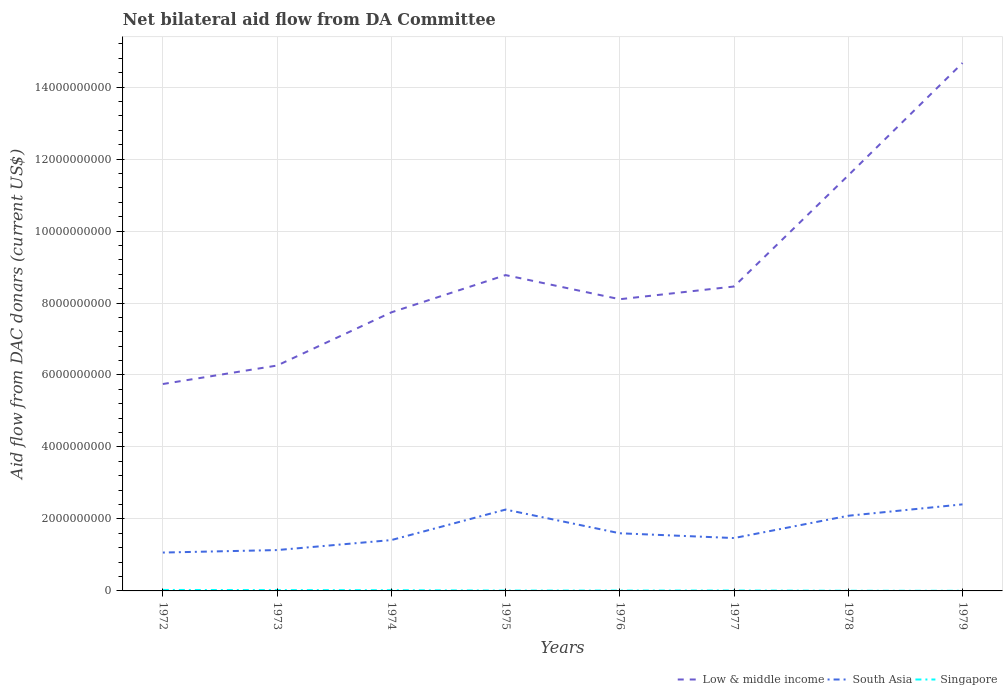Does the line corresponding to South Asia intersect with the line corresponding to Singapore?
Make the answer very short. No. Is the number of lines equal to the number of legend labels?
Offer a terse response. Yes. Across all years, what is the maximum aid flow in in Singapore?
Your answer should be very brief. 3.93e+06. In which year was the aid flow in in Low & middle income maximum?
Provide a short and direct response. 1972. What is the total aid flow in in Low & middle income in the graph?
Make the answer very short. -1.48e+09. What is the difference between the highest and the second highest aid flow in in Singapore?
Offer a very short reply. 2.31e+07. Is the aid flow in in South Asia strictly greater than the aid flow in in Singapore over the years?
Give a very brief answer. No. How many lines are there?
Your response must be concise. 3. Are the values on the major ticks of Y-axis written in scientific E-notation?
Provide a short and direct response. No. Does the graph contain any zero values?
Provide a short and direct response. No. How many legend labels are there?
Make the answer very short. 3. How are the legend labels stacked?
Offer a terse response. Horizontal. What is the title of the graph?
Your response must be concise. Net bilateral aid flow from DA Committee. Does "Botswana" appear as one of the legend labels in the graph?
Your response must be concise. No. What is the label or title of the X-axis?
Your answer should be very brief. Years. What is the label or title of the Y-axis?
Offer a very short reply. Aid flow from DAC donars (current US$). What is the Aid flow from DAC donars (current US$) of Low & middle income in 1972?
Your answer should be very brief. 5.75e+09. What is the Aid flow from DAC donars (current US$) in South Asia in 1972?
Offer a very short reply. 1.07e+09. What is the Aid flow from DAC donars (current US$) in Singapore in 1972?
Your answer should be compact. 2.70e+07. What is the Aid flow from DAC donars (current US$) in Low & middle income in 1973?
Offer a very short reply. 6.26e+09. What is the Aid flow from DAC donars (current US$) in South Asia in 1973?
Your answer should be very brief. 1.14e+09. What is the Aid flow from DAC donars (current US$) of Singapore in 1973?
Make the answer very short. 2.32e+07. What is the Aid flow from DAC donars (current US$) in Low & middle income in 1974?
Provide a short and direct response. 7.74e+09. What is the Aid flow from DAC donars (current US$) of South Asia in 1974?
Ensure brevity in your answer.  1.41e+09. What is the Aid flow from DAC donars (current US$) in Singapore in 1974?
Provide a succinct answer. 1.97e+07. What is the Aid flow from DAC donars (current US$) of Low & middle income in 1975?
Provide a succinct answer. 8.78e+09. What is the Aid flow from DAC donars (current US$) in South Asia in 1975?
Your answer should be compact. 2.26e+09. What is the Aid flow from DAC donars (current US$) of Singapore in 1975?
Provide a short and direct response. 1.00e+07. What is the Aid flow from DAC donars (current US$) in Low & middle income in 1976?
Provide a succinct answer. 8.11e+09. What is the Aid flow from DAC donars (current US$) in South Asia in 1976?
Keep it short and to the point. 1.60e+09. What is the Aid flow from DAC donars (current US$) of Singapore in 1976?
Make the answer very short. 9.98e+06. What is the Aid flow from DAC donars (current US$) in Low & middle income in 1977?
Your answer should be very brief. 8.46e+09. What is the Aid flow from DAC donars (current US$) in South Asia in 1977?
Your answer should be very brief. 1.47e+09. What is the Aid flow from DAC donars (current US$) of Singapore in 1977?
Keep it short and to the point. 1.13e+07. What is the Aid flow from DAC donars (current US$) in Low & middle income in 1978?
Offer a very short reply. 1.15e+1. What is the Aid flow from DAC donars (current US$) in South Asia in 1978?
Your answer should be compact. 2.09e+09. What is the Aid flow from DAC donars (current US$) of Singapore in 1978?
Make the answer very short. 5.19e+06. What is the Aid flow from DAC donars (current US$) of Low & middle income in 1979?
Give a very brief answer. 1.47e+1. What is the Aid flow from DAC donars (current US$) in South Asia in 1979?
Your answer should be compact. 2.40e+09. What is the Aid flow from DAC donars (current US$) of Singapore in 1979?
Your response must be concise. 3.93e+06. Across all years, what is the maximum Aid flow from DAC donars (current US$) of Low & middle income?
Provide a succinct answer. 1.47e+1. Across all years, what is the maximum Aid flow from DAC donars (current US$) of South Asia?
Give a very brief answer. 2.40e+09. Across all years, what is the maximum Aid flow from DAC donars (current US$) of Singapore?
Your answer should be very brief. 2.70e+07. Across all years, what is the minimum Aid flow from DAC donars (current US$) in Low & middle income?
Provide a succinct answer. 5.75e+09. Across all years, what is the minimum Aid flow from DAC donars (current US$) of South Asia?
Offer a terse response. 1.07e+09. Across all years, what is the minimum Aid flow from DAC donars (current US$) of Singapore?
Give a very brief answer. 3.93e+06. What is the total Aid flow from DAC donars (current US$) of Low & middle income in the graph?
Give a very brief answer. 7.13e+1. What is the total Aid flow from DAC donars (current US$) in South Asia in the graph?
Your answer should be compact. 1.34e+1. What is the total Aid flow from DAC donars (current US$) in Singapore in the graph?
Provide a short and direct response. 1.10e+08. What is the difference between the Aid flow from DAC donars (current US$) of Low & middle income in 1972 and that in 1973?
Give a very brief answer. -5.14e+08. What is the difference between the Aid flow from DAC donars (current US$) in South Asia in 1972 and that in 1973?
Provide a short and direct response. -6.90e+07. What is the difference between the Aid flow from DAC donars (current US$) in Singapore in 1972 and that in 1973?
Your answer should be compact. 3.88e+06. What is the difference between the Aid flow from DAC donars (current US$) of Low & middle income in 1972 and that in 1974?
Keep it short and to the point. -1.99e+09. What is the difference between the Aid flow from DAC donars (current US$) of South Asia in 1972 and that in 1974?
Provide a succinct answer. -3.47e+08. What is the difference between the Aid flow from DAC donars (current US$) of Singapore in 1972 and that in 1974?
Offer a very short reply. 7.34e+06. What is the difference between the Aid flow from DAC donars (current US$) of Low & middle income in 1972 and that in 1975?
Your response must be concise. -3.03e+09. What is the difference between the Aid flow from DAC donars (current US$) in South Asia in 1972 and that in 1975?
Provide a succinct answer. -1.19e+09. What is the difference between the Aid flow from DAC donars (current US$) of Singapore in 1972 and that in 1975?
Ensure brevity in your answer.  1.70e+07. What is the difference between the Aid flow from DAC donars (current US$) of Low & middle income in 1972 and that in 1976?
Ensure brevity in your answer.  -2.36e+09. What is the difference between the Aid flow from DAC donars (current US$) in South Asia in 1972 and that in 1976?
Your answer should be compact. -5.35e+08. What is the difference between the Aid flow from DAC donars (current US$) in Singapore in 1972 and that in 1976?
Offer a very short reply. 1.70e+07. What is the difference between the Aid flow from DAC donars (current US$) of Low & middle income in 1972 and that in 1977?
Keep it short and to the point. -2.71e+09. What is the difference between the Aid flow from DAC donars (current US$) of South Asia in 1972 and that in 1977?
Offer a terse response. -4.03e+08. What is the difference between the Aid flow from DAC donars (current US$) in Singapore in 1972 and that in 1977?
Your answer should be very brief. 1.58e+07. What is the difference between the Aid flow from DAC donars (current US$) of Low & middle income in 1972 and that in 1978?
Offer a very short reply. -5.80e+09. What is the difference between the Aid flow from DAC donars (current US$) in South Asia in 1972 and that in 1978?
Offer a very short reply. -1.02e+09. What is the difference between the Aid flow from DAC donars (current US$) of Singapore in 1972 and that in 1978?
Provide a succinct answer. 2.18e+07. What is the difference between the Aid flow from DAC donars (current US$) in Low & middle income in 1972 and that in 1979?
Your answer should be very brief. -8.92e+09. What is the difference between the Aid flow from DAC donars (current US$) in South Asia in 1972 and that in 1979?
Your answer should be very brief. -1.34e+09. What is the difference between the Aid flow from DAC donars (current US$) in Singapore in 1972 and that in 1979?
Keep it short and to the point. 2.31e+07. What is the difference between the Aid flow from DAC donars (current US$) of Low & middle income in 1973 and that in 1974?
Your response must be concise. -1.48e+09. What is the difference between the Aid flow from DAC donars (current US$) of South Asia in 1973 and that in 1974?
Your response must be concise. -2.78e+08. What is the difference between the Aid flow from DAC donars (current US$) in Singapore in 1973 and that in 1974?
Your response must be concise. 3.46e+06. What is the difference between the Aid flow from DAC donars (current US$) of Low & middle income in 1973 and that in 1975?
Your answer should be compact. -2.51e+09. What is the difference between the Aid flow from DAC donars (current US$) in South Asia in 1973 and that in 1975?
Your response must be concise. -1.13e+09. What is the difference between the Aid flow from DAC donars (current US$) in Singapore in 1973 and that in 1975?
Provide a succinct answer. 1.31e+07. What is the difference between the Aid flow from DAC donars (current US$) of Low & middle income in 1973 and that in 1976?
Your answer should be very brief. -1.84e+09. What is the difference between the Aid flow from DAC donars (current US$) of South Asia in 1973 and that in 1976?
Your answer should be very brief. -4.67e+08. What is the difference between the Aid flow from DAC donars (current US$) of Singapore in 1973 and that in 1976?
Keep it short and to the point. 1.32e+07. What is the difference between the Aid flow from DAC donars (current US$) in Low & middle income in 1973 and that in 1977?
Your answer should be compact. -2.20e+09. What is the difference between the Aid flow from DAC donars (current US$) in South Asia in 1973 and that in 1977?
Offer a terse response. -3.34e+08. What is the difference between the Aid flow from DAC donars (current US$) of Singapore in 1973 and that in 1977?
Your answer should be very brief. 1.19e+07. What is the difference between the Aid flow from DAC donars (current US$) in Low & middle income in 1973 and that in 1978?
Offer a very short reply. -5.28e+09. What is the difference between the Aid flow from DAC donars (current US$) in South Asia in 1973 and that in 1978?
Give a very brief answer. -9.53e+08. What is the difference between the Aid flow from DAC donars (current US$) in Singapore in 1973 and that in 1978?
Provide a succinct answer. 1.80e+07. What is the difference between the Aid flow from DAC donars (current US$) of Low & middle income in 1973 and that in 1979?
Your answer should be compact. -8.41e+09. What is the difference between the Aid flow from DAC donars (current US$) in South Asia in 1973 and that in 1979?
Provide a succinct answer. -1.27e+09. What is the difference between the Aid flow from DAC donars (current US$) of Singapore in 1973 and that in 1979?
Offer a terse response. 1.92e+07. What is the difference between the Aid flow from DAC donars (current US$) of Low & middle income in 1974 and that in 1975?
Your answer should be very brief. -1.04e+09. What is the difference between the Aid flow from DAC donars (current US$) of South Asia in 1974 and that in 1975?
Provide a short and direct response. -8.47e+08. What is the difference between the Aid flow from DAC donars (current US$) of Singapore in 1974 and that in 1975?
Offer a very short reply. 9.68e+06. What is the difference between the Aid flow from DAC donars (current US$) of Low & middle income in 1974 and that in 1976?
Your answer should be very brief. -3.65e+08. What is the difference between the Aid flow from DAC donars (current US$) of South Asia in 1974 and that in 1976?
Your response must be concise. -1.89e+08. What is the difference between the Aid flow from DAC donars (current US$) in Singapore in 1974 and that in 1976?
Ensure brevity in your answer.  9.71e+06. What is the difference between the Aid flow from DAC donars (current US$) of Low & middle income in 1974 and that in 1977?
Offer a very short reply. -7.19e+08. What is the difference between the Aid flow from DAC donars (current US$) in South Asia in 1974 and that in 1977?
Give a very brief answer. -5.61e+07. What is the difference between the Aid flow from DAC donars (current US$) in Singapore in 1974 and that in 1977?
Give a very brief answer. 8.41e+06. What is the difference between the Aid flow from DAC donars (current US$) of Low & middle income in 1974 and that in 1978?
Provide a short and direct response. -3.81e+09. What is the difference between the Aid flow from DAC donars (current US$) of South Asia in 1974 and that in 1978?
Ensure brevity in your answer.  -6.76e+08. What is the difference between the Aid flow from DAC donars (current US$) of Singapore in 1974 and that in 1978?
Your response must be concise. 1.45e+07. What is the difference between the Aid flow from DAC donars (current US$) in Low & middle income in 1974 and that in 1979?
Give a very brief answer. -6.93e+09. What is the difference between the Aid flow from DAC donars (current US$) in South Asia in 1974 and that in 1979?
Provide a succinct answer. -9.92e+08. What is the difference between the Aid flow from DAC donars (current US$) in Singapore in 1974 and that in 1979?
Make the answer very short. 1.58e+07. What is the difference between the Aid flow from DAC donars (current US$) of Low & middle income in 1975 and that in 1976?
Offer a very short reply. 6.71e+08. What is the difference between the Aid flow from DAC donars (current US$) of South Asia in 1975 and that in 1976?
Provide a short and direct response. 6.59e+08. What is the difference between the Aid flow from DAC donars (current US$) in Singapore in 1975 and that in 1976?
Your answer should be very brief. 3.00e+04. What is the difference between the Aid flow from DAC donars (current US$) in Low & middle income in 1975 and that in 1977?
Offer a very short reply. 3.17e+08. What is the difference between the Aid flow from DAC donars (current US$) in South Asia in 1975 and that in 1977?
Ensure brevity in your answer.  7.91e+08. What is the difference between the Aid flow from DAC donars (current US$) in Singapore in 1975 and that in 1977?
Your response must be concise. -1.27e+06. What is the difference between the Aid flow from DAC donars (current US$) of Low & middle income in 1975 and that in 1978?
Offer a terse response. -2.77e+09. What is the difference between the Aid flow from DAC donars (current US$) in South Asia in 1975 and that in 1978?
Make the answer very short. 1.72e+08. What is the difference between the Aid flow from DAC donars (current US$) of Singapore in 1975 and that in 1978?
Your answer should be compact. 4.82e+06. What is the difference between the Aid flow from DAC donars (current US$) of Low & middle income in 1975 and that in 1979?
Offer a very short reply. -5.89e+09. What is the difference between the Aid flow from DAC donars (current US$) in South Asia in 1975 and that in 1979?
Give a very brief answer. -1.45e+08. What is the difference between the Aid flow from DAC donars (current US$) of Singapore in 1975 and that in 1979?
Make the answer very short. 6.08e+06. What is the difference between the Aid flow from DAC donars (current US$) of Low & middle income in 1976 and that in 1977?
Your answer should be compact. -3.54e+08. What is the difference between the Aid flow from DAC donars (current US$) of South Asia in 1976 and that in 1977?
Offer a terse response. 1.33e+08. What is the difference between the Aid flow from DAC donars (current US$) of Singapore in 1976 and that in 1977?
Give a very brief answer. -1.30e+06. What is the difference between the Aid flow from DAC donars (current US$) of Low & middle income in 1976 and that in 1978?
Make the answer very short. -3.44e+09. What is the difference between the Aid flow from DAC donars (current US$) of South Asia in 1976 and that in 1978?
Provide a succinct answer. -4.87e+08. What is the difference between the Aid flow from DAC donars (current US$) in Singapore in 1976 and that in 1978?
Offer a terse response. 4.79e+06. What is the difference between the Aid flow from DAC donars (current US$) of Low & middle income in 1976 and that in 1979?
Your answer should be very brief. -6.56e+09. What is the difference between the Aid flow from DAC donars (current US$) in South Asia in 1976 and that in 1979?
Make the answer very short. -8.03e+08. What is the difference between the Aid flow from DAC donars (current US$) of Singapore in 1976 and that in 1979?
Your answer should be very brief. 6.05e+06. What is the difference between the Aid flow from DAC donars (current US$) in Low & middle income in 1977 and that in 1978?
Offer a terse response. -3.09e+09. What is the difference between the Aid flow from DAC donars (current US$) in South Asia in 1977 and that in 1978?
Your response must be concise. -6.20e+08. What is the difference between the Aid flow from DAC donars (current US$) of Singapore in 1977 and that in 1978?
Offer a very short reply. 6.09e+06. What is the difference between the Aid flow from DAC donars (current US$) in Low & middle income in 1977 and that in 1979?
Your answer should be compact. -6.21e+09. What is the difference between the Aid flow from DAC donars (current US$) in South Asia in 1977 and that in 1979?
Offer a terse response. -9.36e+08. What is the difference between the Aid flow from DAC donars (current US$) of Singapore in 1977 and that in 1979?
Make the answer very short. 7.35e+06. What is the difference between the Aid flow from DAC donars (current US$) in Low & middle income in 1978 and that in 1979?
Ensure brevity in your answer.  -3.12e+09. What is the difference between the Aid flow from DAC donars (current US$) of South Asia in 1978 and that in 1979?
Your response must be concise. -3.16e+08. What is the difference between the Aid flow from DAC donars (current US$) in Singapore in 1978 and that in 1979?
Provide a short and direct response. 1.26e+06. What is the difference between the Aid flow from DAC donars (current US$) of Low & middle income in 1972 and the Aid flow from DAC donars (current US$) of South Asia in 1973?
Keep it short and to the point. 4.61e+09. What is the difference between the Aid flow from DAC donars (current US$) of Low & middle income in 1972 and the Aid flow from DAC donars (current US$) of Singapore in 1973?
Your answer should be very brief. 5.73e+09. What is the difference between the Aid flow from DAC donars (current US$) of South Asia in 1972 and the Aid flow from DAC donars (current US$) of Singapore in 1973?
Give a very brief answer. 1.04e+09. What is the difference between the Aid flow from DAC donars (current US$) in Low & middle income in 1972 and the Aid flow from DAC donars (current US$) in South Asia in 1974?
Keep it short and to the point. 4.34e+09. What is the difference between the Aid flow from DAC donars (current US$) in Low & middle income in 1972 and the Aid flow from DAC donars (current US$) in Singapore in 1974?
Your answer should be compact. 5.73e+09. What is the difference between the Aid flow from DAC donars (current US$) of South Asia in 1972 and the Aid flow from DAC donars (current US$) of Singapore in 1974?
Make the answer very short. 1.05e+09. What is the difference between the Aid flow from DAC donars (current US$) of Low & middle income in 1972 and the Aid flow from DAC donars (current US$) of South Asia in 1975?
Offer a very short reply. 3.49e+09. What is the difference between the Aid flow from DAC donars (current US$) in Low & middle income in 1972 and the Aid flow from DAC donars (current US$) in Singapore in 1975?
Keep it short and to the point. 5.74e+09. What is the difference between the Aid flow from DAC donars (current US$) of South Asia in 1972 and the Aid flow from DAC donars (current US$) of Singapore in 1975?
Your response must be concise. 1.06e+09. What is the difference between the Aid flow from DAC donars (current US$) of Low & middle income in 1972 and the Aid flow from DAC donars (current US$) of South Asia in 1976?
Your answer should be compact. 4.15e+09. What is the difference between the Aid flow from DAC donars (current US$) in Low & middle income in 1972 and the Aid flow from DAC donars (current US$) in Singapore in 1976?
Ensure brevity in your answer.  5.74e+09. What is the difference between the Aid flow from DAC donars (current US$) in South Asia in 1972 and the Aid flow from DAC donars (current US$) in Singapore in 1976?
Your answer should be compact. 1.06e+09. What is the difference between the Aid flow from DAC donars (current US$) in Low & middle income in 1972 and the Aid flow from DAC donars (current US$) in South Asia in 1977?
Give a very brief answer. 4.28e+09. What is the difference between the Aid flow from DAC donars (current US$) of Low & middle income in 1972 and the Aid flow from DAC donars (current US$) of Singapore in 1977?
Provide a short and direct response. 5.74e+09. What is the difference between the Aid flow from DAC donars (current US$) of South Asia in 1972 and the Aid flow from DAC donars (current US$) of Singapore in 1977?
Provide a short and direct response. 1.05e+09. What is the difference between the Aid flow from DAC donars (current US$) of Low & middle income in 1972 and the Aid flow from DAC donars (current US$) of South Asia in 1978?
Your answer should be very brief. 3.66e+09. What is the difference between the Aid flow from DAC donars (current US$) of Low & middle income in 1972 and the Aid flow from DAC donars (current US$) of Singapore in 1978?
Make the answer very short. 5.74e+09. What is the difference between the Aid flow from DAC donars (current US$) of South Asia in 1972 and the Aid flow from DAC donars (current US$) of Singapore in 1978?
Ensure brevity in your answer.  1.06e+09. What is the difference between the Aid flow from DAC donars (current US$) of Low & middle income in 1972 and the Aid flow from DAC donars (current US$) of South Asia in 1979?
Offer a terse response. 3.34e+09. What is the difference between the Aid flow from DAC donars (current US$) of Low & middle income in 1972 and the Aid flow from DAC donars (current US$) of Singapore in 1979?
Provide a succinct answer. 5.75e+09. What is the difference between the Aid flow from DAC donars (current US$) of South Asia in 1972 and the Aid flow from DAC donars (current US$) of Singapore in 1979?
Your answer should be compact. 1.06e+09. What is the difference between the Aid flow from DAC donars (current US$) of Low & middle income in 1973 and the Aid flow from DAC donars (current US$) of South Asia in 1974?
Your answer should be very brief. 4.85e+09. What is the difference between the Aid flow from DAC donars (current US$) in Low & middle income in 1973 and the Aid flow from DAC donars (current US$) in Singapore in 1974?
Provide a succinct answer. 6.24e+09. What is the difference between the Aid flow from DAC donars (current US$) of South Asia in 1973 and the Aid flow from DAC donars (current US$) of Singapore in 1974?
Ensure brevity in your answer.  1.12e+09. What is the difference between the Aid flow from DAC donars (current US$) in Low & middle income in 1973 and the Aid flow from DAC donars (current US$) in South Asia in 1975?
Your answer should be very brief. 4.00e+09. What is the difference between the Aid flow from DAC donars (current US$) of Low & middle income in 1973 and the Aid flow from DAC donars (current US$) of Singapore in 1975?
Give a very brief answer. 6.25e+09. What is the difference between the Aid flow from DAC donars (current US$) in South Asia in 1973 and the Aid flow from DAC donars (current US$) in Singapore in 1975?
Ensure brevity in your answer.  1.13e+09. What is the difference between the Aid flow from DAC donars (current US$) of Low & middle income in 1973 and the Aid flow from DAC donars (current US$) of South Asia in 1976?
Provide a succinct answer. 4.66e+09. What is the difference between the Aid flow from DAC donars (current US$) in Low & middle income in 1973 and the Aid flow from DAC donars (current US$) in Singapore in 1976?
Offer a terse response. 6.25e+09. What is the difference between the Aid flow from DAC donars (current US$) of South Asia in 1973 and the Aid flow from DAC donars (current US$) of Singapore in 1976?
Provide a succinct answer. 1.13e+09. What is the difference between the Aid flow from DAC donars (current US$) in Low & middle income in 1973 and the Aid flow from DAC donars (current US$) in South Asia in 1977?
Your answer should be very brief. 4.79e+09. What is the difference between the Aid flow from DAC donars (current US$) of Low & middle income in 1973 and the Aid flow from DAC donars (current US$) of Singapore in 1977?
Ensure brevity in your answer.  6.25e+09. What is the difference between the Aid flow from DAC donars (current US$) of South Asia in 1973 and the Aid flow from DAC donars (current US$) of Singapore in 1977?
Give a very brief answer. 1.12e+09. What is the difference between the Aid flow from DAC donars (current US$) in Low & middle income in 1973 and the Aid flow from DAC donars (current US$) in South Asia in 1978?
Give a very brief answer. 4.17e+09. What is the difference between the Aid flow from DAC donars (current US$) of Low & middle income in 1973 and the Aid flow from DAC donars (current US$) of Singapore in 1978?
Offer a terse response. 6.26e+09. What is the difference between the Aid flow from DAC donars (current US$) of South Asia in 1973 and the Aid flow from DAC donars (current US$) of Singapore in 1978?
Ensure brevity in your answer.  1.13e+09. What is the difference between the Aid flow from DAC donars (current US$) of Low & middle income in 1973 and the Aid flow from DAC donars (current US$) of South Asia in 1979?
Provide a succinct answer. 3.86e+09. What is the difference between the Aid flow from DAC donars (current US$) of Low & middle income in 1973 and the Aid flow from DAC donars (current US$) of Singapore in 1979?
Provide a succinct answer. 6.26e+09. What is the difference between the Aid flow from DAC donars (current US$) of South Asia in 1973 and the Aid flow from DAC donars (current US$) of Singapore in 1979?
Give a very brief answer. 1.13e+09. What is the difference between the Aid flow from DAC donars (current US$) of Low & middle income in 1974 and the Aid flow from DAC donars (current US$) of South Asia in 1975?
Give a very brief answer. 5.48e+09. What is the difference between the Aid flow from DAC donars (current US$) in Low & middle income in 1974 and the Aid flow from DAC donars (current US$) in Singapore in 1975?
Offer a terse response. 7.73e+09. What is the difference between the Aid flow from DAC donars (current US$) of South Asia in 1974 and the Aid flow from DAC donars (current US$) of Singapore in 1975?
Your response must be concise. 1.40e+09. What is the difference between the Aid flow from DAC donars (current US$) of Low & middle income in 1974 and the Aid flow from DAC donars (current US$) of South Asia in 1976?
Your response must be concise. 6.14e+09. What is the difference between the Aid flow from DAC donars (current US$) in Low & middle income in 1974 and the Aid flow from DAC donars (current US$) in Singapore in 1976?
Give a very brief answer. 7.73e+09. What is the difference between the Aid flow from DAC donars (current US$) in South Asia in 1974 and the Aid flow from DAC donars (current US$) in Singapore in 1976?
Offer a terse response. 1.40e+09. What is the difference between the Aid flow from DAC donars (current US$) of Low & middle income in 1974 and the Aid flow from DAC donars (current US$) of South Asia in 1977?
Ensure brevity in your answer.  6.27e+09. What is the difference between the Aid flow from DAC donars (current US$) in Low & middle income in 1974 and the Aid flow from DAC donars (current US$) in Singapore in 1977?
Offer a terse response. 7.73e+09. What is the difference between the Aid flow from DAC donars (current US$) of South Asia in 1974 and the Aid flow from DAC donars (current US$) of Singapore in 1977?
Offer a terse response. 1.40e+09. What is the difference between the Aid flow from DAC donars (current US$) in Low & middle income in 1974 and the Aid flow from DAC donars (current US$) in South Asia in 1978?
Give a very brief answer. 5.65e+09. What is the difference between the Aid flow from DAC donars (current US$) of Low & middle income in 1974 and the Aid flow from DAC donars (current US$) of Singapore in 1978?
Offer a terse response. 7.74e+09. What is the difference between the Aid flow from DAC donars (current US$) in South Asia in 1974 and the Aid flow from DAC donars (current US$) in Singapore in 1978?
Make the answer very short. 1.41e+09. What is the difference between the Aid flow from DAC donars (current US$) in Low & middle income in 1974 and the Aid flow from DAC donars (current US$) in South Asia in 1979?
Keep it short and to the point. 5.34e+09. What is the difference between the Aid flow from DAC donars (current US$) in Low & middle income in 1974 and the Aid flow from DAC donars (current US$) in Singapore in 1979?
Your response must be concise. 7.74e+09. What is the difference between the Aid flow from DAC donars (current US$) in South Asia in 1974 and the Aid flow from DAC donars (current US$) in Singapore in 1979?
Provide a succinct answer. 1.41e+09. What is the difference between the Aid flow from DAC donars (current US$) in Low & middle income in 1975 and the Aid flow from DAC donars (current US$) in South Asia in 1976?
Your answer should be very brief. 7.17e+09. What is the difference between the Aid flow from DAC donars (current US$) in Low & middle income in 1975 and the Aid flow from DAC donars (current US$) in Singapore in 1976?
Offer a terse response. 8.77e+09. What is the difference between the Aid flow from DAC donars (current US$) in South Asia in 1975 and the Aid flow from DAC donars (current US$) in Singapore in 1976?
Offer a terse response. 2.25e+09. What is the difference between the Aid flow from DAC donars (current US$) in Low & middle income in 1975 and the Aid flow from DAC donars (current US$) in South Asia in 1977?
Offer a terse response. 7.31e+09. What is the difference between the Aid flow from DAC donars (current US$) in Low & middle income in 1975 and the Aid flow from DAC donars (current US$) in Singapore in 1977?
Provide a succinct answer. 8.76e+09. What is the difference between the Aid flow from DAC donars (current US$) of South Asia in 1975 and the Aid flow from DAC donars (current US$) of Singapore in 1977?
Make the answer very short. 2.25e+09. What is the difference between the Aid flow from DAC donars (current US$) of Low & middle income in 1975 and the Aid flow from DAC donars (current US$) of South Asia in 1978?
Provide a succinct answer. 6.69e+09. What is the difference between the Aid flow from DAC donars (current US$) of Low & middle income in 1975 and the Aid flow from DAC donars (current US$) of Singapore in 1978?
Give a very brief answer. 8.77e+09. What is the difference between the Aid flow from DAC donars (current US$) of South Asia in 1975 and the Aid flow from DAC donars (current US$) of Singapore in 1978?
Give a very brief answer. 2.26e+09. What is the difference between the Aid flow from DAC donars (current US$) of Low & middle income in 1975 and the Aid flow from DAC donars (current US$) of South Asia in 1979?
Provide a short and direct response. 6.37e+09. What is the difference between the Aid flow from DAC donars (current US$) of Low & middle income in 1975 and the Aid flow from DAC donars (current US$) of Singapore in 1979?
Offer a very short reply. 8.77e+09. What is the difference between the Aid flow from DAC donars (current US$) in South Asia in 1975 and the Aid flow from DAC donars (current US$) in Singapore in 1979?
Provide a short and direct response. 2.26e+09. What is the difference between the Aid flow from DAC donars (current US$) of Low & middle income in 1976 and the Aid flow from DAC donars (current US$) of South Asia in 1977?
Your answer should be very brief. 6.64e+09. What is the difference between the Aid flow from DAC donars (current US$) of Low & middle income in 1976 and the Aid flow from DAC donars (current US$) of Singapore in 1977?
Offer a terse response. 8.09e+09. What is the difference between the Aid flow from DAC donars (current US$) in South Asia in 1976 and the Aid flow from DAC donars (current US$) in Singapore in 1977?
Ensure brevity in your answer.  1.59e+09. What is the difference between the Aid flow from DAC donars (current US$) in Low & middle income in 1976 and the Aid flow from DAC donars (current US$) in South Asia in 1978?
Your answer should be compact. 6.02e+09. What is the difference between the Aid flow from DAC donars (current US$) of Low & middle income in 1976 and the Aid flow from DAC donars (current US$) of Singapore in 1978?
Your answer should be compact. 8.10e+09. What is the difference between the Aid flow from DAC donars (current US$) in South Asia in 1976 and the Aid flow from DAC donars (current US$) in Singapore in 1978?
Provide a short and direct response. 1.60e+09. What is the difference between the Aid flow from DAC donars (current US$) in Low & middle income in 1976 and the Aid flow from DAC donars (current US$) in South Asia in 1979?
Your answer should be compact. 5.70e+09. What is the difference between the Aid flow from DAC donars (current US$) of Low & middle income in 1976 and the Aid flow from DAC donars (current US$) of Singapore in 1979?
Offer a terse response. 8.10e+09. What is the difference between the Aid flow from DAC donars (current US$) of South Asia in 1976 and the Aid flow from DAC donars (current US$) of Singapore in 1979?
Keep it short and to the point. 1.60e+09. What is the difference between the Aid flow from DAC donars (current US$) in Low & middle income in 1977 and the Aid flow from DAC donars (current US$) in South Asia in 1978?
Keep it short and to the point. 6.37e+09. What is the difference between the Aid flow from DAC donars (current US$) of Low & middle income in 1977 and the Aid flow from DAC donars (current US$) of Singapore in 1978?
Provide a short and direct response. 8.45e+09. What is the difference between the Aid flow from DAC donars (current US$) in South Asia in 1977 and the Aid flow from DAC donars (current US$) in Singapore in 1978?
Ensure brevity in your answer.  1.46e+09. What is the difference between the Aid flow from DAC donars (current US$) of Low & middle income in 1977 and the Aid flow from DAC donars (current US$) of South Asia in 1979?
Your response must be concise. 6.05e+09. What is the difference between the Aid flow from DAC donars (current US$) in Low & middle income in 1977 and the Aid flow from DAC donars (current US$) in Singapore in 1979?
Keep it short and to the point. 8.46e+09. What is the difference between the Aid flow from DAC donars (current US$) of South Asia in 1977 and the Aid flow from DAC donars (current US$) of Singapore in 1979?
Give a very brief answer. 1.47e+09. What is the difference between the Aid flow from DAC donars (current US$) of Low & middle income in 1978 and the Aid flow from DAC donars (current US$) of South Asia in 1979?
Make the answer very short. 9.14e+09. What is the difference between the Aid flow from DAC donars (current US$) of Low & middle income in 1978 and the Aid flow from DAC donars (current US$) of Singapore in 1979?
Keep it short and to the point. 1.15e+1. What is the difference between the Aid flow from DAC donars (current US$) of South Asia in 1978 and the Aid flow from DAC donars (current US$) of Singapore in 1979?
Keep it short and to the point. 2.08e+09. What is the average Aid flow from DAC donars (current US$) of Low & middle income per year?
Give a very brief answer. 8.91e+09. What is the average Aid flow from DAC donars (current US$) of South Asia per year?
Your response must be concise. 1.68e+09. What is the average Aid flow from DAC donars (current US$) of Singapore per year?
Provide a short and direct response. 1.38e+07. In the year 1972, what is the difference between the Aid flow from DAC donars (current US$) of Low & middle income and Aid flow from DAC donars (current US$) of South Asia?
Provide a short and direct response. 4.68e+09. In the year 1972, what is the difference between the Aid flow from DAC donars (current US$) of Low & middle income and Aid flow from DAC donars (current US$) of Singapore?
Your response must be concise. 5.72e+09. In the year 1972, what is the difference between the Aid flow from DAC donars (current US$) in South Asia and Aid flow from DAC donars (current US$) in Singapore?
Make the answer very short. 1.04e+09. In the year 1973, what is the difference between the Aid flow from DAC donars (current US$) in Low & middle income and Aid flow from DAC donars (current US$) in South Asia?
Offer a terse response. 5.13e+09. In the year 1973, what is the difference between the Aid flow from DAC donars (current US$) of Low & middle income and Aid flow from DAC donars (current US$) of Singapore?
Give a very brief answer. 6.24e+09. In the year 1973, what is the difference between the Aid flow from DAC donars (current US$) in South Asia and Aid flow from DAC donars (current US$) in Singapore?
Offer a very short reply. 1.11e+09. In the year 1974, what is the difference between the Aid flow from DAC donars (current US$) of Low & middle income and Aid flow from DAC donars (current US$) of South Asia?
Give a very brief answer. 6.33e+09. In the year 1974, what is the difference between the Aid flow from DAC donars (current US$) of Low & middle income and Aid flow from DAC donars (current US$) of Singapore?
Keep it short and to the point. 7.72e+09. In the year 1974, what is the difference between the Aid flow from DAC donars (current US$) in South Asia and Aid flow from DAC donars (current US$) in Singapore?
Your response must be concise. 1.39e+09. In the year 1975, what is the difference between the Aid flow from DAC donars (current US$) in Low & middle income and Aid flow from DAC donars (current US$) in South Asia?
Offer a terse response. 6.52e+09. In the year 1975, what is the difference between the Aid flow from DAC donars (current US$) of Low & middle income and Aid flow from DAC donars (current US$) of Singapore?
Give a very brief answer. 8.77e+09. In the year 1975, what is the difference between the Aid flow from DAC donars (current US$) of South Asia and Aid flow from DAC donars (current US$) of Singapore?
Ensure brevity in your answer.  2.25e+09. In the year 1976, what is the difference between the Aid flow from DAC donars (current US$) of Low & middle income and Aid flow from DAC donars (current US$) of South Asia?
Provide a short and direct response. 6.50e+09. In the year 1976, what is the difference between the Aid flow from DAC donars (current US$) in Low & middle income and Aid flow from DAC donars (current US$) in Singapore?
Provide a short and direct response. 8.10e+09. In the year 1976, what is the difference between the Aid flow from DAC donars (current US$) of South Asia and Aid flow from DAC donars (current US$) of Singapore?
Your answer should be very brief. 1.59e+09. In the year 1977, what is the difference between the Aid flow from DAC donars (current US$) in Low & middle income and Aid flow from DAC donars (current US$) in South Asia?
Offer a very short reply. 6.99e+09. In the year 1977, what is the difference between the Aid flow from DAC donars (current US$) of Low & middle income and Aid flow from DAC donars (current US$) of Singapore?
Make the answer very short. 8.45e+09. In the year 1977, what is the difference between the Aid flow from DAC donars (current US$) of South Asia and Aid flow from DAC donars (current US$) of Singapore?
Your answer should be compact. 1.46e+09. In the year 1978, what is the difference between the Aid flow from DAC donars (current US$) of Low & middle income and Aid flow from DAC donars (current US$) of South Asia?
Keep it short and to the point. 9.46e+09. In the year 1978, what is the difference between the Aid flow from DAC donars (current US$) of Low & middle income and Aid flow from DAC donars (current US$) of Singapore?
Your answer should be compact. 1.15e+1. In the year 1978, what is the difference between the Aid flow from DAC donars (current US$) of South Asia and Aid flow from DAC donars (current US$) of Singapore?
Give a very brief answer. 2.08e+09. In the year 1979, what is the difference between the Aid flow from DAC donars (current US$) in Low & middle income and Aid flow from DAC donars (current US$) in South Asia?
Provide a succinct answer. 1.23e+1. In the year 1979, what is the difference between the Aid flow from DAC donars (current US$) of Low & middle income and Aid flow from DAC donars (current US$) of Singapore?
Provide a short and direct response. 1.47e+1. In the year 1979, what is the difference between the Aid flow from DAC donars (current US$) in South Asia and Aid flow from DAC donars (current US$) in Singapore?
Keep it short and to the point. 2.40e+09. What is the ratio of the Aid flow from DAC donars (current US$) in Low & middle income in 1972 to that in 1973?
Your answer should be very brief. 0.92. What is the ratio of the Aid flow from DAC donars (current US$) in South Asia in 1972 to that in 1973?
Your answer should be very brief. 0.94. What is the ratio of the Aid flow from DAC donars (current US$) of Singapore in 1972 to that in 1973?
Make the answer very short. 1.17. What is the ratio of the Aid flow from DAC donars (current US$) of Low & middle income in 1972 to that in 1974?
Provide a succinct answer. 0.74. What is the ratio of the Aid flow from DAC donars (current US$) of South Asia in 1972 to that in 1974?
Offer a very short reply. 0.75. What is the ratio of the Aid flow from DAC donars (current US$) in Singapore in 1972 to that in 1974?
Your response must be concise. 1.37. What is the ratio of the Aid flow from DAC donars (current US$) of Low & middle income in 1972 to that in 1975?
Offer a very short reply. 0.66. What is the ratio of the Aid flow from DAC donars (current US$) in South Asia in 1972 to that in 1975?
Your response must be concise. 0.47. What is the ratio of the Aid flow from DAC donars (current US$) of Singapore in 1972 to that in 1975?
Your answer should be compact. 2.7. What is the ratio of the Aid flow from DAC donars (current US$) of Low & middle income in 1972 to that in 1976?
Offer a very short reply. 0.71. What is the ratio of the Aid flow from DAC donars (current US$) of South Asia in 1972 to that in 1976?
Give a very brief answer. 0.67. What is the ratio of the Aid flow from DAC donars (current US$) of Singapore in 1972 to that in 1976?
Your response must be concise. 2.71. What is the ratio of the Aid flow from DAC donars (current US$) of Low & middle income in 1972 to that in 1977?
Make the answer very short. 0.68. What is the ratio of the Aid flow from DAC donars (current US$) of South Asia in 1972 to that in 1977?
Provide a succinct answer. 0.73. What is the ratio of the Aid flow from DAC donars (current US$) of Singapore in 1972 to that in 1977?
Make the answer very short. 2.4. What is the ratio of the Aid flow from DAC donars (current US$) in Low & middle income in 1972 to that in 1978?
Your answer should be compact. 0.5. What is the ratio of the Aid flow from DAC donars (current US$) of South Asia in 1972 to that in 1978?
Make the answer very short. 0.51. What is the ratio of the Aid flow from DAC donars (current US$) of Singapore in 1972 to that in 1978?
Keep it short and to the point. 5.21. What is the ratio of the Aid flow from DAC donars (current US$) of Low & middle income in 1972 to that in 1979?
Offer a terse response. 0.39. What is the ratio of the Aid flow from DAC donars (current US$) in South Asia in 1972 to that in 1979?
Provide a short and direct response. 0.44. What is the ratio of the Aid flow from DAC donars (current US$) in Singapore in 1972 to that in 1979?
Offer a very short reply. 6.88. What is the ratio of the Aid flow from DAC donars (current US$) of Low & middle income in 1973 to that in 1974?
Keep it short and to the point. 0.81. What is the ratio of the Aid flow from DAC donars (current US$) in South Asia in 1973 to that in 1974?
Provide a short and direct response. 0.8. What is the ratio of the Aid flow from DAC donars (current US$) of Singapore in 1973 to that in 1974?
Offer a terse response. 1.18. What is the ratio of the Aid flow from DAC donars (current US$) in Low & middle income in 1973 to that in 1975?
Make the answer very short. 0.71. What is the ratio of the Aid flow from DAC donars (current US$) in South Asia in 1973 to that in 1975?
Your answer should be compact. 0.5. What is the ratio of the Aid flow from DAC donars (current US$) of Singapore in 1973 to that in 1975?
Offer a very short reply. 2.31. What is the ratio of the Aid flow from DAC donars (current US$) in Low & middle income in 1973 to that in 1976?
Keep it short and to the point. 0.77. What is the ratio of the Aid flow from DAC donars (current US$) in South Asia in 1973 to that in 1976?
Provide a short and direct response. 0.71. What is the ratio of the Aid flow from DAC donars (current US$) of Singapore in 1973 to that in 1976?
Offer a very short reply. 2.32. What is the ratio of the Aid flow from DAC donars (current US$) of Low & middle income in 1973 to that in 1977?
Your response must be concise. 0.74. What is the ratio of the Aid flow from DAC donars (current US$) of South Asia in 1973 to that in 1977?
Your answer should be very brief. 0.77. What is the ratio of the Aid flow from DAC donars (current US$) in Singapore in 1973 to that in 1977?
Provide a short and direct response. 2.05. What is the ratio of the Aid flow from DAC donars (current US$) in Low & middle income in 1973 to that in 1978?
Provide a succinct answer. 0.54. What is the ratio of the Aid flow from DAC donars (current US$) of South Asia in 1973 to that in 1978?
Give a very brief answer. 0.54. What is the ratio of the Aid flow from DAC donars (current US$) in Singapore in 1973 to that in 1978?
Your answer should be very brief. 4.46. What is the ratio of the Aid flow from DAC donars (current US$) in Low & middle income in 1973 to that in 1979?
Your response must be concise. 0.43. What is the ratio of the Aid flow from DAC donars (current US$) in South Asia in 1973 to that in 1979?
Provide a short and direct response. 0.47. What is the ratio of the Aid flow from DAC donars (current US$) of Singapore in 1973 to that in 1979?
Provide a succinct answer. 5.89. What is the ratio of the Aid flow from DAC donars (current US$) in Low & middle income in 1974 to that in 1975?
Keep it short and to the point. 0.88. What is the ratio of the Aid flow from DAC donars (current US$) of South Asia in 1974 to that in 1975?
Your response must be concise. 0.63. What is the ratio of the Aid flow from DAC donars (current US$) of Singapore in 1974 to that in 1975?
Your response must be concise. 1.97. What is the ratio of the Aid flow from DAC donars (current US$) of Low & middle income in 1974 to that in 1976?
Offer a terse response. 0.95. What is the ratio of the Aid flow from DAC donars (current US$) of South Asia in 1974 to that in 1976?
Offer a terse response. 0.88. What is the ratio of the Aid flow from DAC donars (current US$) in Singapore in 1974 to that in 1976?
Offer a terse response. 1.97. What is the ratio of the Aid flow from DAC donars (current US$) in Low & middle income in 1974 to that in 1977?
Provide a succinct answer. 0.92. What is the ratio of the Aid flow from DAC donars (current US$) in South Asia in 1974 to that in 1977?
Provide a short and direct response. 0.96. What is the ratio of the Aid flow from DAC donars (current US$) of Singapore in 1974 to that in 1977?
Provide a succinct answer. 1.75. What is the ratio of the Aid flow from DAC donars (current US$) of Low & middle income in 1974 to that in 1978?
Make the answer very short. 0.67. What is the ratio of the Aid flow from DAC donars (current US$) in South Asia in 1974 to that in 1978?
Give a very brief answer. 0.68. What is the ratio of the Aid flow from DAC donars (current US$) of Singapore in 1974 to that in 1978?
Give a very brief answer. 3.79. What is the ratio of the Aid flow from DAC donars (current US$) of Low & middle income in 1974 to that in 1979?
Ensure brevity in your answer.  0.53. What is the ratio of the Aid flow from DAC donars (current US$) of South Asia in 1974 to that in 1979?
Make the answer very short. 0.59. What is the ratio of the Aid flow from DAC donars (current US$) of Singapore in 1974 to that in 1979?
Provide a short and direct response. 5.01. What is the ratio of the Aid flow from DAC donars (current US$) in Low & middle income in 1975 to that in 1976?
Provide a short and direct response. 1.08. What is the ratio of the Aid flow from DAC donars (current US$) in South Asia in 1975 to that in 1976?
Offer a very short reply. 1.41. What is the ratio of the Aid flow from DAC donars (current US$) of Singapore in 1975 to that in 1976?
Ensure brevity in your answer.  1. What is the ratio of the Aid flow from DAC donars (current US$) in Low & middle income in 1975 to that in 1977?
Your response must be concise. 1.04. What is the ratio of the Aid flow from DAC donars (current US$) of South Asia in 1975 to that in 1977?
Your answer should be compact. 1.54. What is the ratio of the Aid flow from DAC donars (current US$) in Singapore in 1975 to that in 1977?
Provide a short and direct response. 0.89. What is the ratio of the Aid flow from DAC donars (current US$) of Low & middle income in 1975 to that in 1978?
Your answer should be compact. 0.76. What is the ratio of the Aid flow from DAC donars (current US$) of South Asia in 1975 to that in 1978?
Your answer should be compact. 1.08. What is the ratio of the Aid flow from DAC donars (current US$) in Singapore in 1975 to that in 1978?
Your answer should be compact. 1.93. What is the ratio of the Aid flow from DAC donars (current US$) of Low & middle income in 1975 to that in 1979?
Your response must be concise. 0.6. What is the ratio of the Aid flow from DAC donars (current US$) in South Asia in 1975 to that in 1979?
Your response must be concise. 0.94. What is the ratio of the Aid flow from DAC donars (current US$) of Singapore in 1975 to that in 1979?
Offer a very short reply. 2.55. What is the ratio of the Aid flow from DAC donars (current US$) of Low & middle income in 1976 to that in 1977?
Your answer should be compact. 0.96. What is the ratio of the Aid flow from DAC donars (current US$) of South Asia in 1976 to that in 1977?
Your answer should be compact. 1.09. What is the ratio of the Aid flow from DAC donars (current US$) of Singapore in 1976 to that in 1977?
Offer a very short reply. 0.88. What is the ratio of the Aid flow from DAC donars (current US$) in Low & middle income in 1976 to that in 1978?
Provide a succinct answer. 0.7. What is the ratio of the Aid flow from DAC donars (current US$) of South Asia in 1976 to that in 1978?
Make the answer very short. 0.77. What is the ratio of the Aid flow from DAC donars (current US$) of Singapore in 1976 to that in 1978?
Ensure brevity in your answer.  1.92. What is the ratio of the Aid flow from DAC donars (current US$) of Low & middle income in 1976 to that in 1979?
Ensure brevity in your answer.  0.55. What is the ratio of the Aid flow from DAC donars (current US$) of South Asia in 1976 to that in 1979?
Your response must be concise. 0.67. What is the ratio of the Aid flow from DAC donars (current US$) in Singapore in 1976 to that in 1979?
Keep it short and to the point. 2.54. What is the ratio of the Aid flow from DAC donars (current US$) of Low & middle income in 1977 to that in 1978?
Ensure brevity in your answer.  0.73. What is the ratio of the Aid flow from DAC donars (current US$) of South Asia in 1977 to that in 1978?
Make the answer very short. 0.7. What is the ratio of the Aid flow from DAC donars (current US$) of Singapore in 1977 to that in 1978?
Offer a very short reply. 2.17. What is the ratio of the Aid flow from DAC donars (current US$) in Low & middle income in 1977 to that in 1979?
Your answer should be compact. 0.58. What is the ratio of the Aid flow from DAC donars (current US$) in South Asia in 1977 to that in 1979?
Keep it short and to the point. 0.61. What is the ratio of the Aid flow from DAC donars (current US$) in Singapore in 1977 to that in 1979?
Provide a succinct answer. 2.87. What is the ratio of the Aid flow from DAC donars (current US$) of Low & middle income in 1978 to that in 1979?
Give a very brief answer. 0.79. What is the ratio of the Aid flow from DAC donars (current US$) of South Asia in 1978 to that in 1979?
Keep it short and to the point. 0.87. What is the ratio of the Aid flow from DAC donars (current US$) in Singapore in 1978 to that in 1979?
Make the answer very short. 1.32. What is the difference between the highest and the second highest Aid flow from DAC donars (current US$) of Low & middle income?
Provide a short and direct response. 3.12e+09. What is the difference between the highest and the second highest Aid flow from DAC donars (current US$) in South Asia?
Your response must be concise. 1.45e+08. What is the difference between the highest and the second highest Aid flow from DAC donars (current US$) of Singapore?
Make the answer very short. 3.88e+06. What is the difference between the highest and the lowest Aid flow from DAC donars (current US$) of Low & middle income?
Provide a succinct answer. 8.92e+09. What is the difference between the highest and the lowest Aid flow from DAC donars (current US$) of South Asia?
Make the answer very short. 1.34e+09. What is the difference between the highest and the lowest Aid flow from DAC donars (current US$) in Singapore?
Your answer should be very brief. 2.31e+07. 